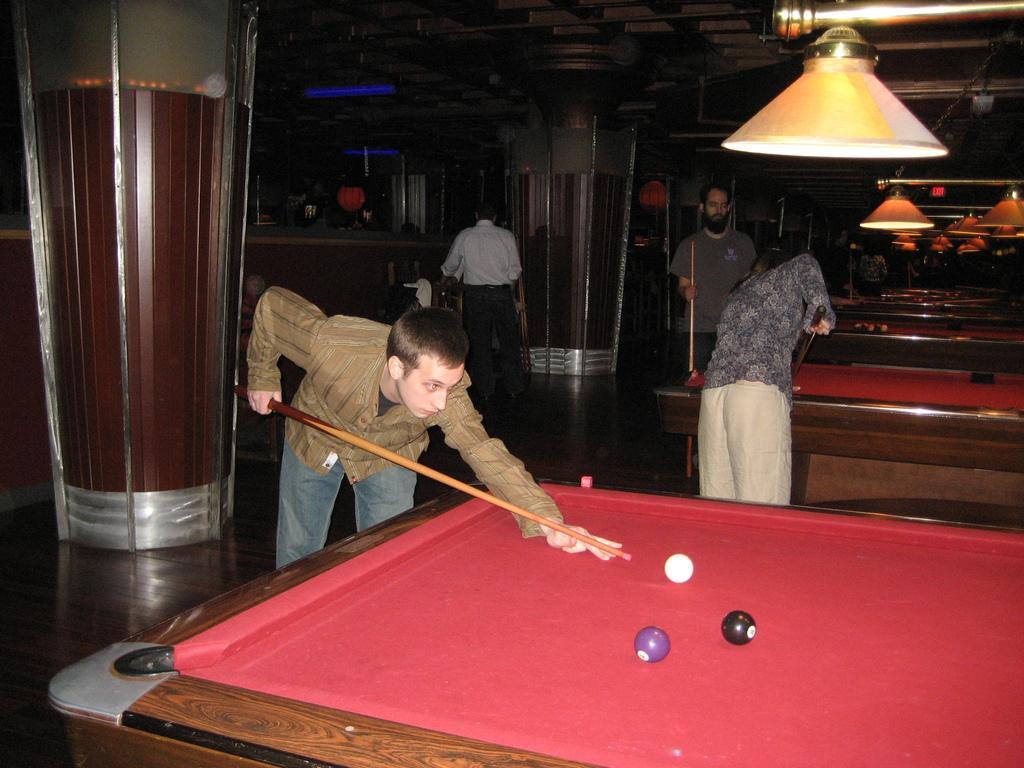Can you describe this image briefly? Here we can see a three persons playing a snooker. Here we can see a person standing and he is on the top center. 